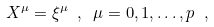Convert formula to latex. <formula><loc_0><loc_0><loc_500><loc_500>X ^ { \mu } = \xi ^ { \mu } \ , \ \mu = 0 , 1 , \dots , p \ ,</formula> 